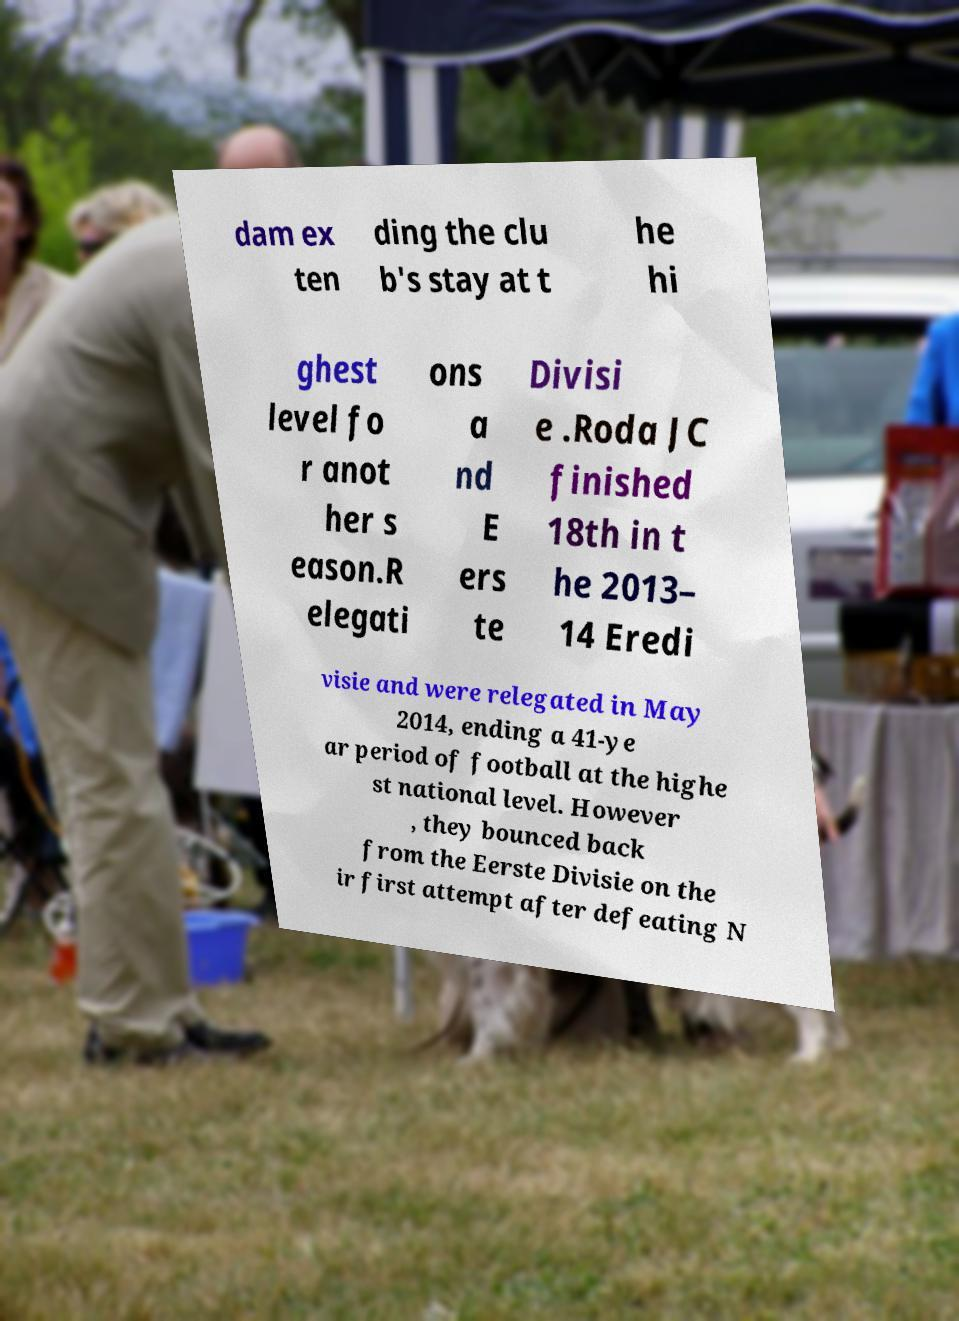Could you extract and type out the text from this image? dam ex ten ding the clu b's stay at t he hi ghest level fo r anot her s eason.R elegati ons a nd E ers te Divisi e .Roda JC finished 18th in t he 2013– 14 Eredi visie and were relegated in May 2014, ending a 41-ye ar period of football at the highe st national level. However , they bounced back from the Eerste Divisie on the ir first attempt after defeating N 